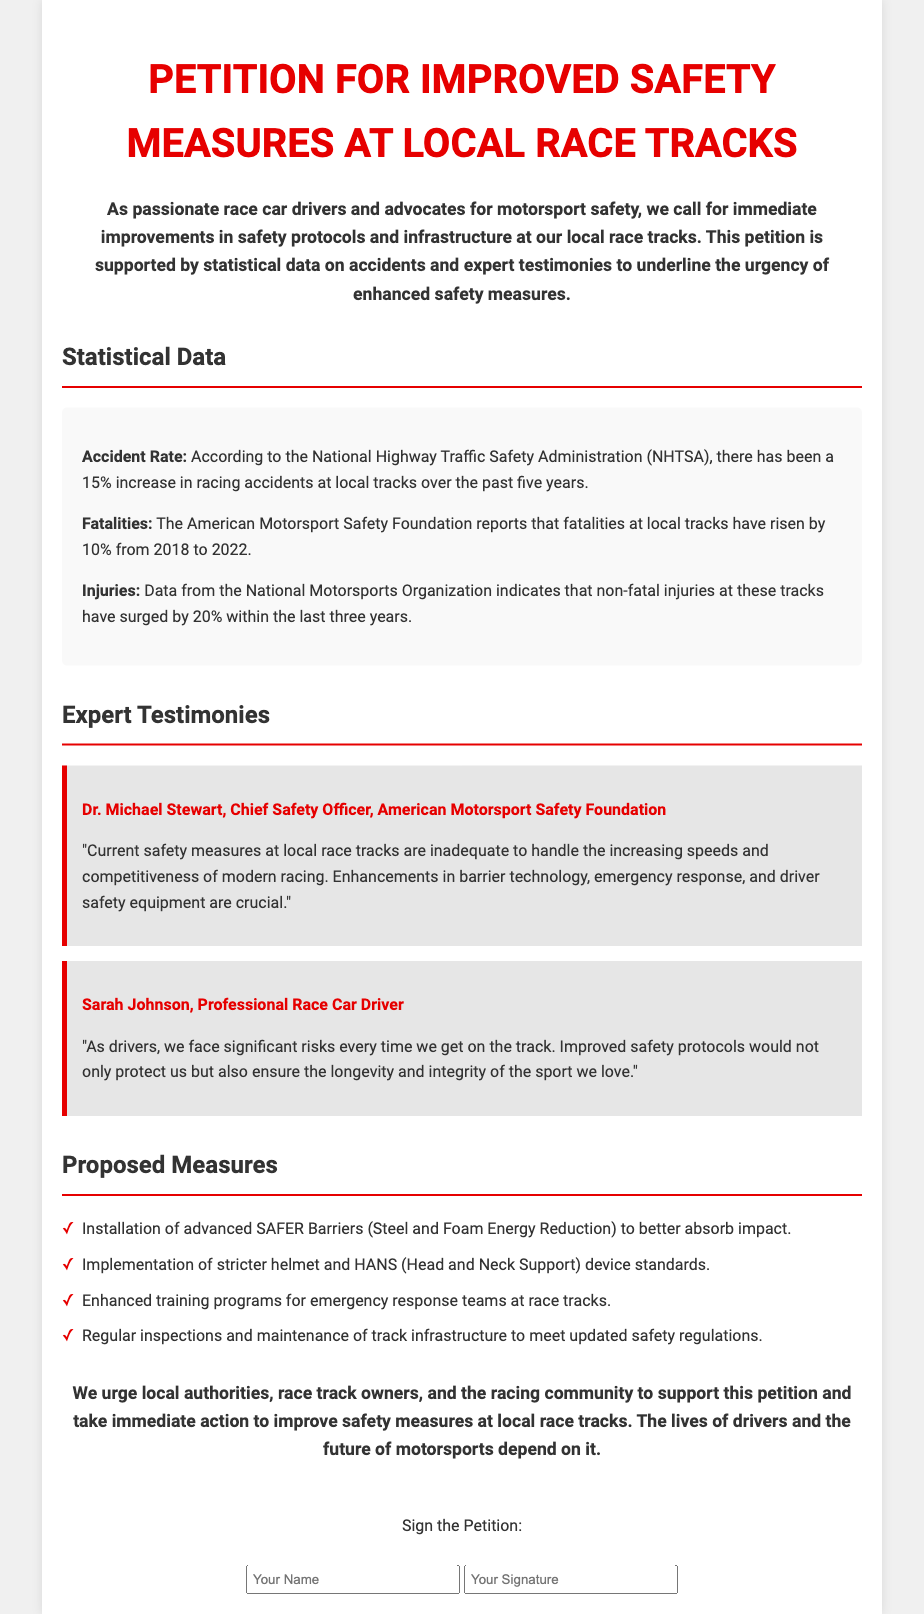What is the title of the petition? The title of the petition is explicitly stated at the beginning of the document.
Answer: Petition for Improved Safety Measures at Local Race Tracks What is the recent percentage increase in racing accidents? The document cites a specific percentage increase in racing accidents over the last five years.
Answer: 15% Who is the Chief Safety Officer of the American Motorsport Safety Foundation? The document provides the name of the Chief Safety Officer as mentioned in the expert testimonies section.
Answer: Dr. Michael Stewart What type of barriers is proposed for installation? The petition outlines specific safety enhancements, including the type of barriers for impact absorption.
Answer: SAFER Barriers What was the percentage rise in fatalities at local tracks from 2018 to 2022? The document explicitly provides the percentage rise in fatalities reported.
Answer: 10% Which expert testified about the need for improved safety protocols? The document lists individuals who provided expert testimonies regarding safety measures.
Answer: Sarah Johnson What is one of the proposed measures related to emergency teams? The petition includes proposed measures and specifies improvements related to emergency response.
Answer: Enhanced training programs for emergency response teams What is the main conclusion of the petition? The document summarizes the overall goal and urgency of the petition in its concluding remarks.
Answer: The lives of drivers and the future of motorsports depend on it 